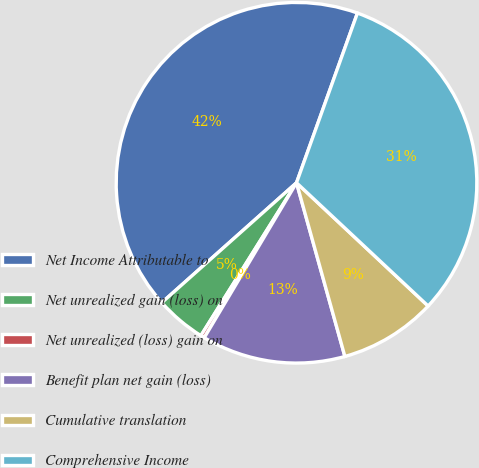<chart> <loc_0><loc_0><loc_500><loc_500><pie_chart><fcel>Net Income Attributable to<fcel>Net unrealized gain (loss) on<fcel>Net unrealized (loss) gain on<fcel>Benefit plan net gain (loss)<fcel>Cumulative translation<fcel>Comprehensive Income<nl><fcel>42.06%<fcel>4.53%<fcel>0.35%<fcel>12.87%<fcel>8.7%<fcel>31.49%<nl></chart> 